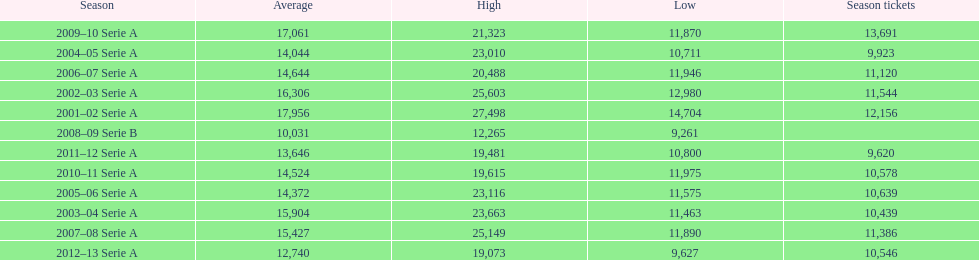How many seasons at the stadio ennio tardini had 11,000 or more season tickets? 5. 